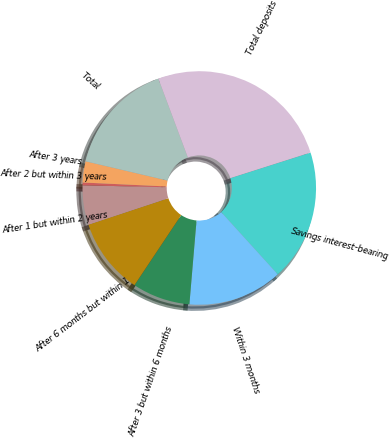<chart> <loc_0><loc_0><loc_500><loc_500><pie_chart><fcel>Savings interest-bearing<fcel>Within 3 months<fcel>After 3 but within 6 months<fcel>After 6 months but within 1<fcel>After 1 but within 2 years<fcel>After 2 but within 3 years<fcel>After 3 years<fcel>Total<fcel>Total deposits<nl><fcel>18.17%<fcel>13.09%<fcel>8.01%<fcel>10.55%<fcel>5.46%<fcel>0.38%<fcel>2.92%<fcel>15.63%<fcel>25.79%<nl></chart> 